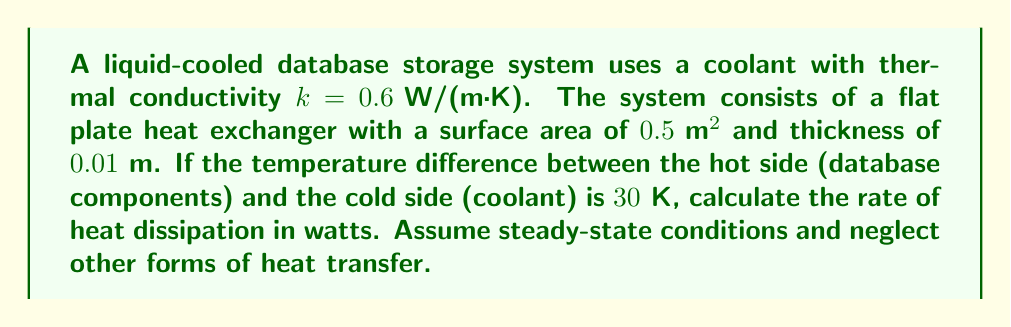Teach me how to tackle this problem. To solve this problem, we'll use Fourier's Law of Heat Conduction, which is given by the equation:

$$ Q = -kA \frac{dT}{dx} $$

Where:
$Q$ = rate of heat transfer (W)
$k$ = thermal conductivity (W/(m·K))
$A$ = surface area (m²)
$\frac{dT}{dx}$ = temperature gradient (K/m)

Given:
$k = 0.6 \text{ W/(m·K)}$
$A = 0.5 \text{ m}^2$
$\Delta T = 30 \text{ K}$
$\Delta x = 0.01 \text{ m}$

Step 1: Calculate the temperature gradient
$\frac{dT}{dx} = \frac{\Delta T}{\Delta x} = \frac{30 \text{ K}}{0.01 \text{ m}} = 3000 \text{ K/m}$

Step 2: Apply Fourier's Law
$Q = kA \frac{dT}{dx}$ (note the negative sign is removed as we're interested in the magnitude)

Step 3: Substitute the values and calculate
$Q = (0.6 \text{ W/(m·K)}) \cdot (0.5 \text{ m}^2) \cdot (3000 \text{ K/m})$
$Q = 900 \text{ W}$

Therefore, the rate of heat dissipation in the liquid-cooled database storage system is 900 watts.
Answer: $900 \text{ W}$ 